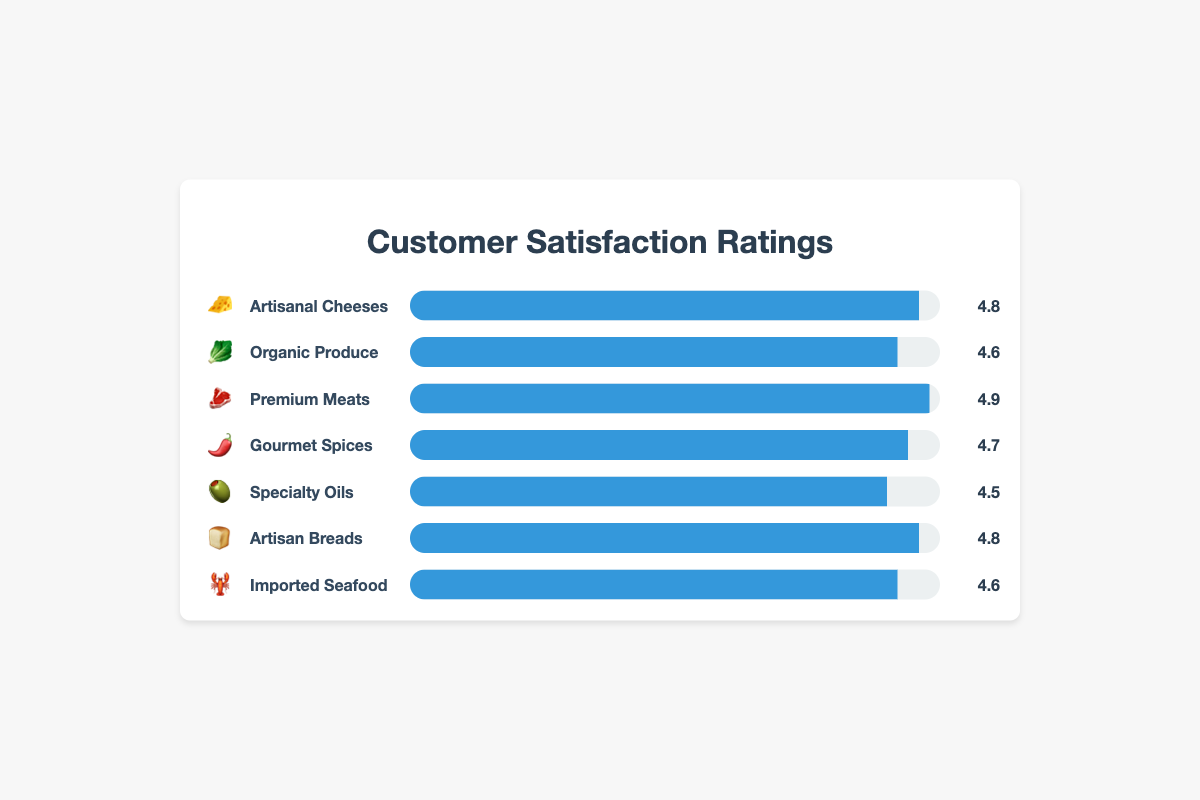Which product category has the highest customer satisfaction rating? The chart shows different categories with their satisfaction ratings on a scale from 0 to 5. By looking at the chart, the highest rating of 4.9 is given to the "Premium Meats" category 🥩.
Answer: Premium Meats What is the average customer satisfaction rating across all categories? To find the average, sum all satisfaction ratings (4.8 + 4.6 + 4.9 + 4.7 + 4.5 + 4.8 + 4.6) and divide by the number of categories (7): (4.8 + 4.6 + 4.9 + 4.7 + 4.5 + 4.8 + 4.6) / 7 = 4.7
Answer: 4.7 Which two categories have the same customer satisfaction rating, and what is the rating? By checking the ratings visually, both "Artisanal Cheeses" 🧀 and "Artisan Breads" 🍞 have the same rating of 4.8.
Answer: Artisanal Cheeses and Artisan Breads, 4.8 What is the difference in customer satisfaction between the "Specialty Oils" and "Premium Meats" categories? The ratings can be observed and compared directly on the chart: 4.9 (Premium Meats) - 4.5 (Specialty Oils) = 0.4
Answer: 0.4 Rank the categories from highest to lowest customer satisfaction The chart shows the ratings for each category. Ordered from highest to lowest, they are:
1. Premium Meats 🥩 (4.9)
2. Artisanal Cheeses 🧀 (4.8), Artisan Breads 🍞 (4.8)
3. Gourmet Spices 🌶️ (4.7)
4. Organic Produce 🥬 (4.6), Imported Seafood 🦞 (4.6)
5. Specialty Oils 🫒 (4.5)
Answer: Premium Meats, Artisanal Cheeses, Artisan Breads, Gourmet Spices, Organic Produce, Imported Seafood, Specialty Oils Which category has the lowest customer satisfaction rating? From the chart, the lowest rating is 4.5, which belongs to "Specialty Oils" 🫒.
Answer: Specialty Oils How many categories have a satisfaction rating of 4.7 or higher? By examining the chart, the categories with a satisfaction rating of 4.7 or higher are:
- Artisanal Cheeses 🧀 (4.8)
- Organic Produce 🥬 (4.6)
- Premium Meats 🥩 (4.9)
- Gourmet Spices 🌶️ (4.7)
- Artisan Breads 🍞 (4.8)
This gives a total of 5 categories.
Answer: 5 